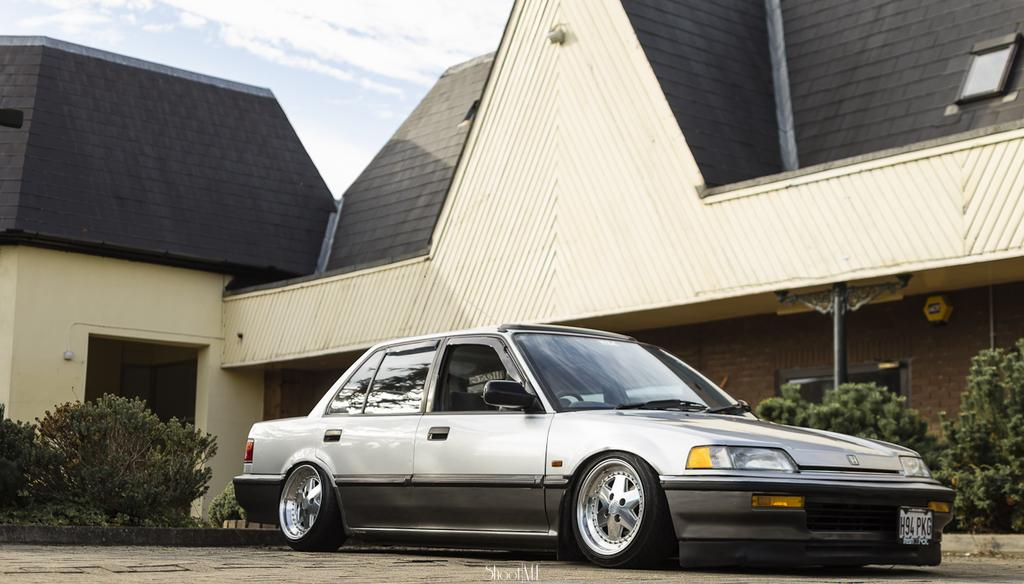What is the main subject of the image? The main subject of the image is a car. What is the car's current state in the image? The car is parked. What can be seen in the background of the image? In the background, there are shrubs, a brick wall, pillars, a wooden house, and the sky with clouds. What type of glue is being used to hold the house together in the image? There is no glue present in the image, and the wooden house is not being held together by any glue. What type of celery can be seen growing in the background of the image? There is no celery present in the image; the background features shrubs, a brick wall, pillars, a wooden house, and the sky with clouds. 